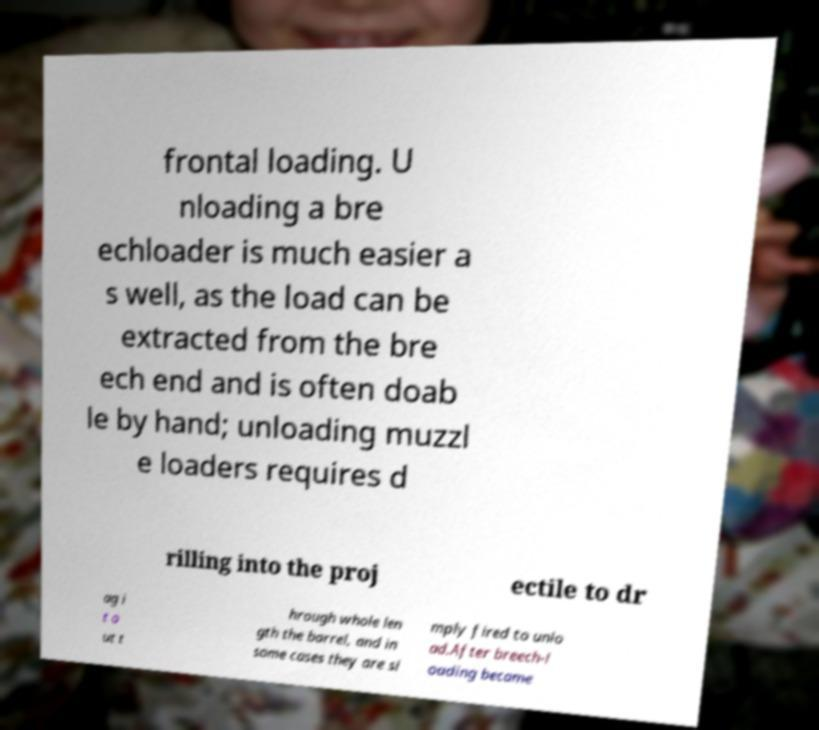For documentation purposes, I need the text within this image transcribed. Could you provide that? frontal loading. U nloading a bre echloader is much easier a s well, as the load can be extracted from the bre ech end and is often doab le by hand; unloading muzzl e loaders requires d rilling into the proj ectile to dr ag i t o ut t hrough whole len gth the barrel, and in some cases they are si mply fired to unlo ad.After breech-l oading became 